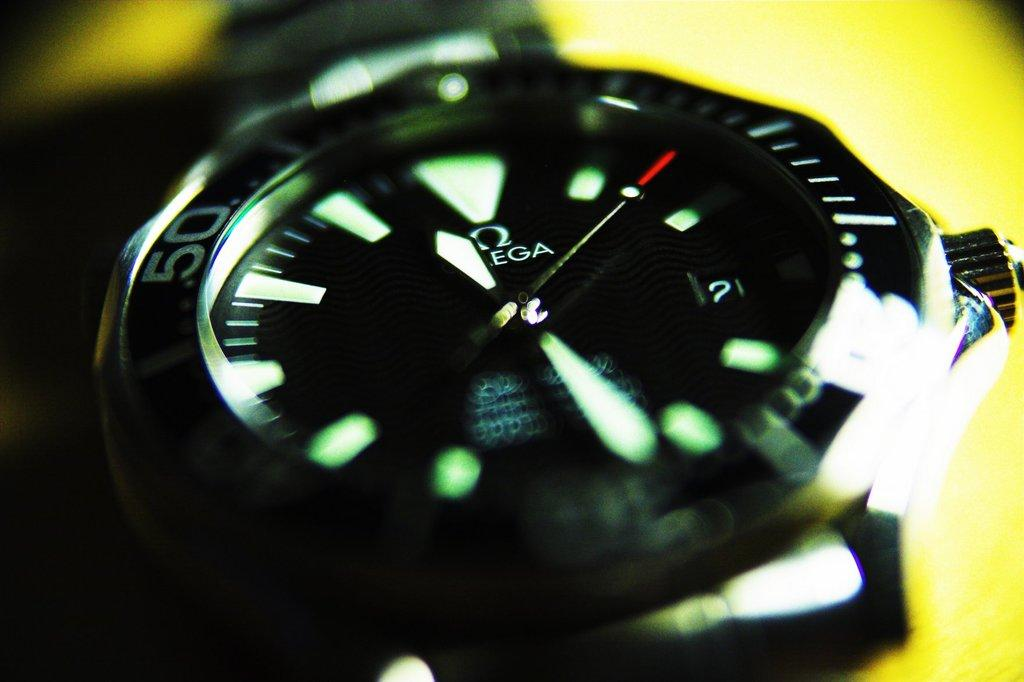<image>
Relay a brief, clear account of the picture shown. An Omega black wristwatch that is lit up in glow in the dark green. 